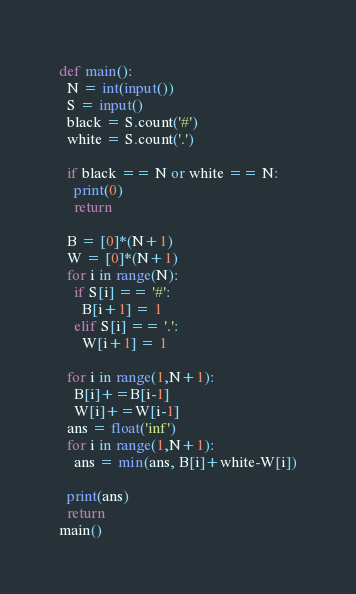<code> <loc_0><loc_0><loc_500><loc_500><_Python_>def main():
  N = int(input())
  S = input()
  black = S.count('#')
  white = S.count('.')

  if black == N or white == N:
    print(0)
    return 
 	
  B = [0]*(N+1)
  W = [0]*(N+1)
  for i in range(N):
    if S[i] == '#':
      B[i+1] = 1
    elif S[i] == '.':
      W[i+1] = 1
  
  for i in range(1,N+1):
    B[i]+=B[i-1]
    W[i]+=W[i-1]
  ans = float('inf')
  for i in range(1,N+1):
    ans = min(ans, B[i]+white-W[i])
  
  print(ans)
  return
main()</code> 